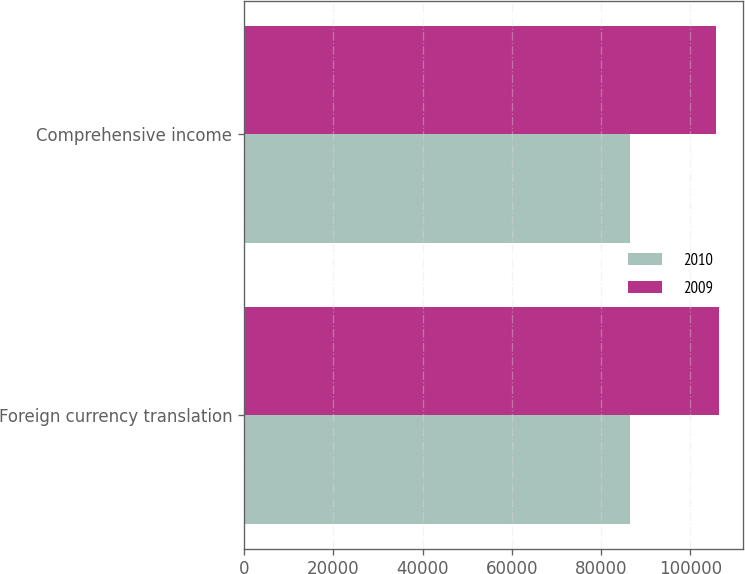<chart> <loc_0><loc_0><loc_500><loc_500><stacked_bar_chart><ecel><fcel>Foreign currency translation<fcel>Comprehensive income<nl><fcel>2010<fcel>86375<fcel>86375<nl><fcel>2009<fcel>106523<fcel>105777<nl></chart> 